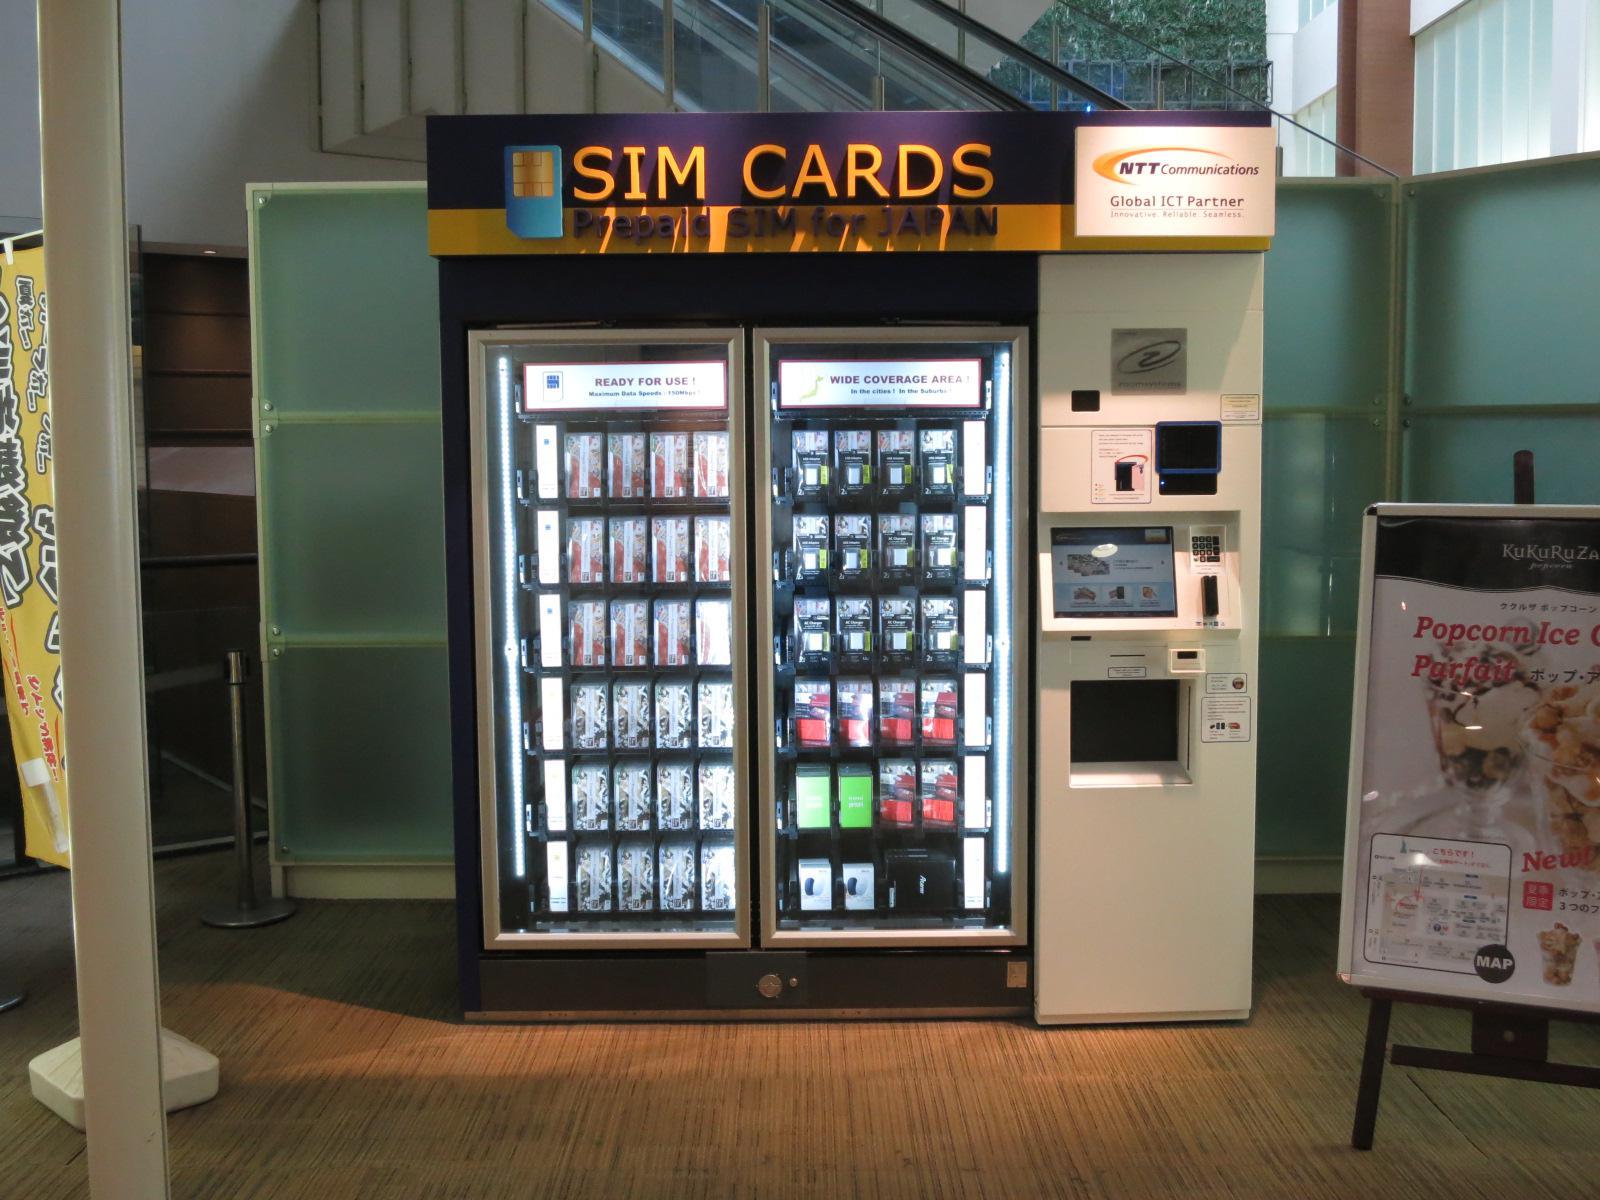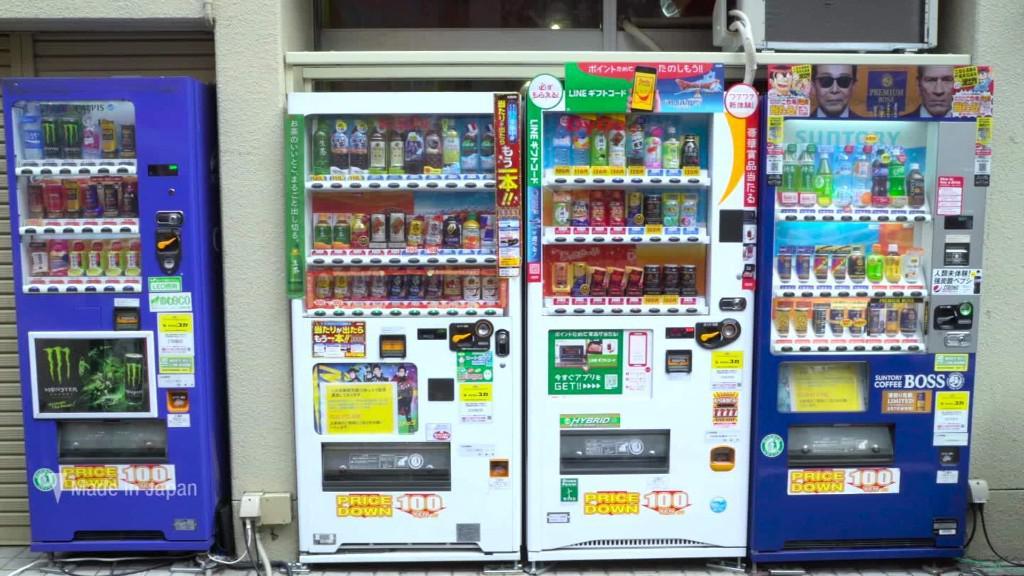The first image is the image on the left, the second image is the image on the right. Evaluate the accuracy of this statement regarding the images: "Red canapes cover some of the machines outside.". Is it true? Answer yes or no. No. The first image is the image on the left, the second image is the image on the right. Given the left and right images, does the statement "Each image depicts a long row of outdoor red, white, and blue vending machines parked in front of a green area, with pavement in front." hold true? Answer yes or no. No. 